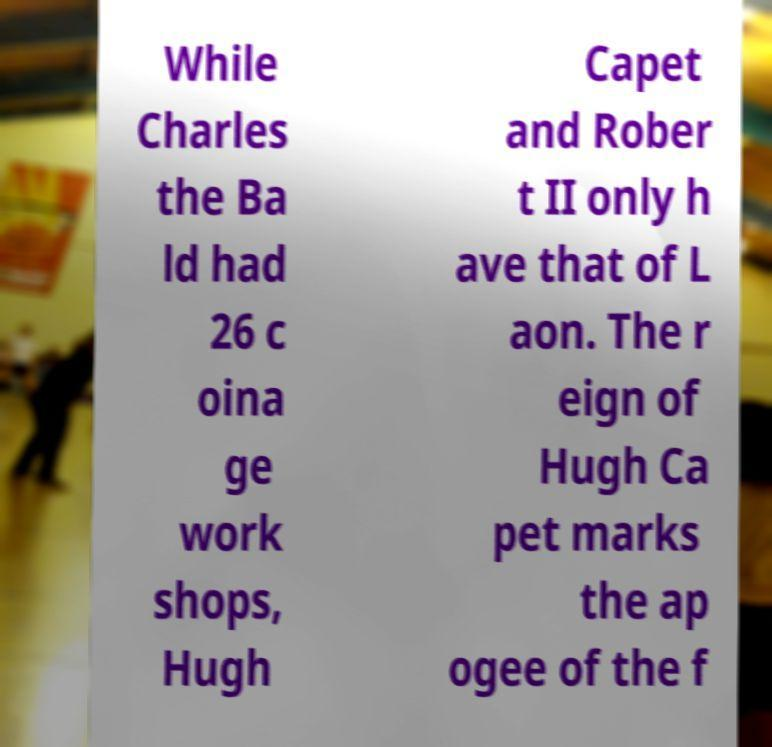Can you read and provide the text displayed in the image?This photo seems to have some interesting text. Can you extract and type it out for me? While Charles the Ba ld had 26 c oina ge work shops, Hugh Capet and Rober t II only h ave that of L aon. The r eign of Hugh Ca pet marks the ap ogee of the f 